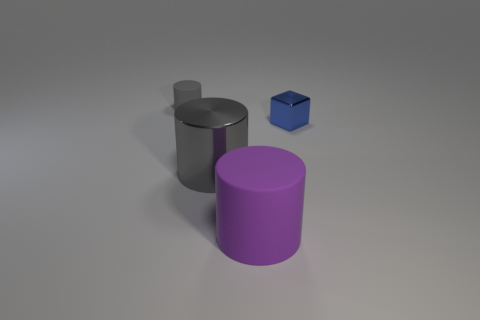Add 2 large gray metallic cylinders. How many objects exist? 6 Subtract all blocks. How many objects are left? 3 Subtract all tiny rubber things. Subtract all gray objects. How many objects are left? 1 Add 3 purple rubber cylinders. How many purple rubber cylinders are left? 4 Add 4 blue blocks. How many blue blocks exist? 5 Subtract 0 green balls. How many objects are left? 4 